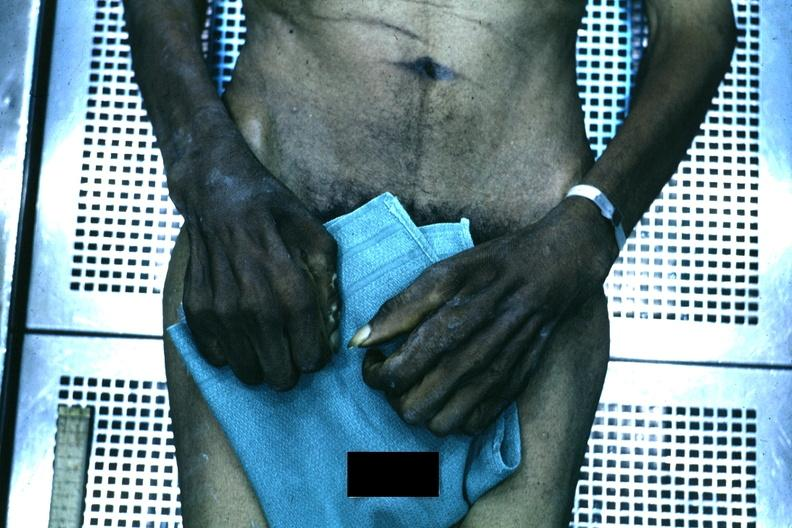how is good example of muscle atrophy said to be to syringomyelia?
Answer the question using a single word or phrase. Due 